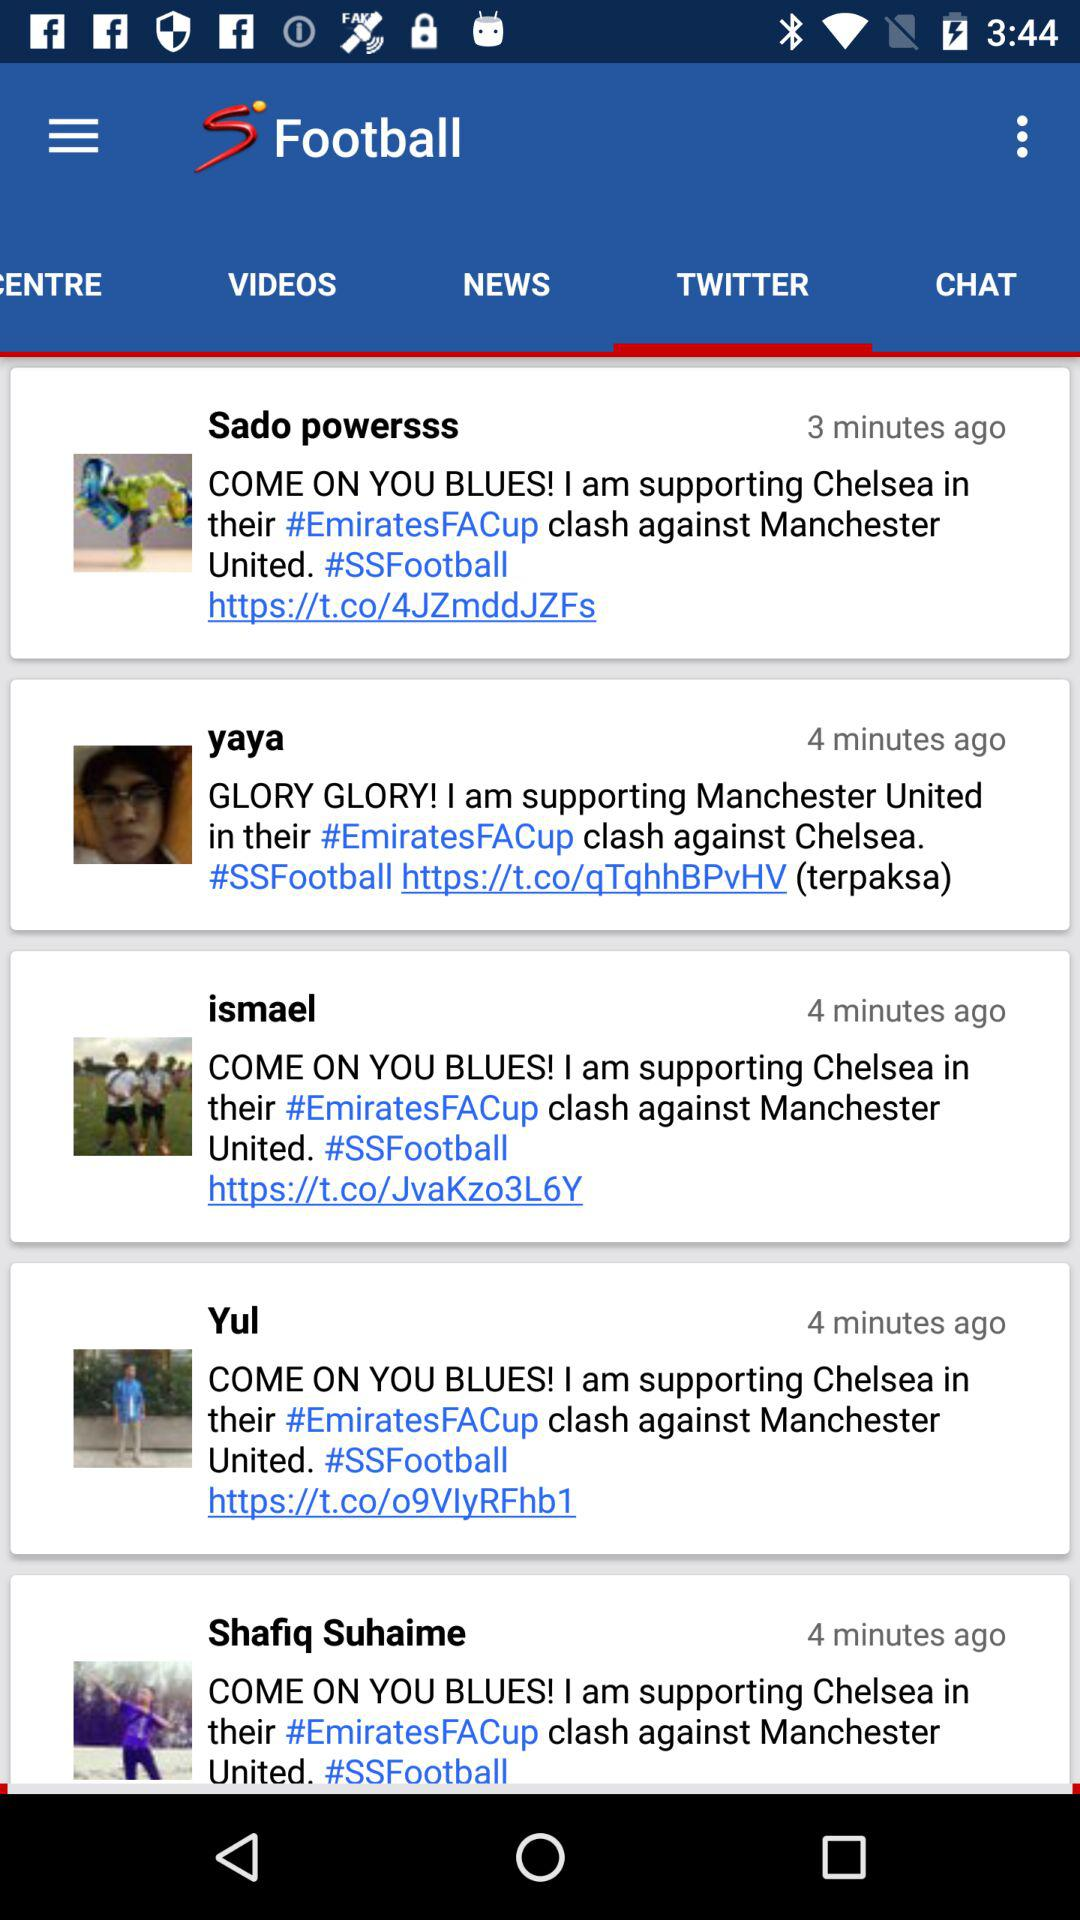How many more people are supporting Chelsea than Manchester United?
Answer the question using a single word or phrase. 3 